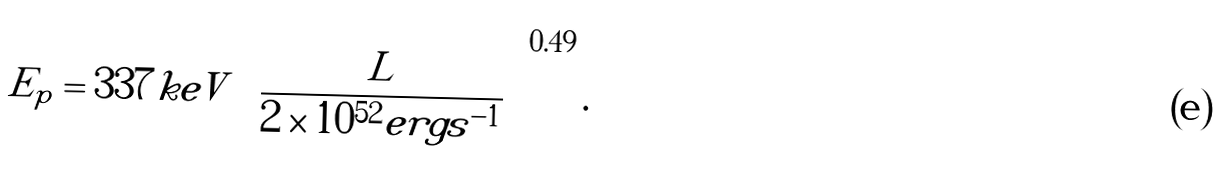Convert formula to latex. <formula><loc_0><loc_0><loc_500><loc_500>E _ { p } = 3 3 7 k e V \left ( \frac { L } { 2 \times 1 0 ^ { 5 2 } e r g s ^ { - 1 } } \right ) ^ { 0 . 4 9 } .</formula> 